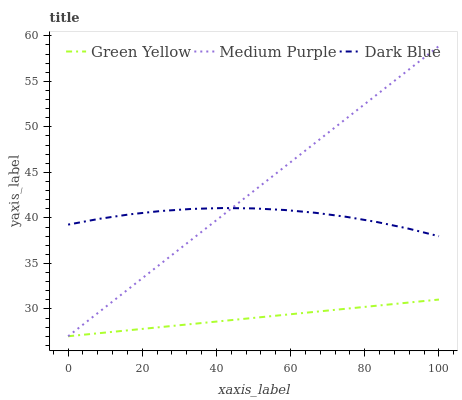Does Green Yellow have the minimum area under the curve?
Answer yes or no. Yes. Does Medium Purple have the maximum area under the curve?
Answer yes or no. Yes. Does Dark Blue have the minimum area under the curve?
Answer yes or no. No. Does Dark Blue have the maximum area under the curve?
Answer yes or no. No. Is Green Yellow the smoothest?
Answer yes or no. Yes. Is Dark Blue the roughest?
Answer yes or no. Yes. Is Dark Blue the smoothest?
Answer yes or no. No. Is Green Yellow the roughest?
Answer yes or no. No. Does Dark Blue have the lowest value?
Answer yes or no. No. Does Dark Blue have the highest value?
Answer yes or no. No. Is Green Yellow less than Dark Blue?
Answer yes or no. Yes. Is Dark Blue greater than Green Yellow?
Answer yes or no. Yes. Does Green Yellow intersect Dark Blue?
Answer yes or no. No. 